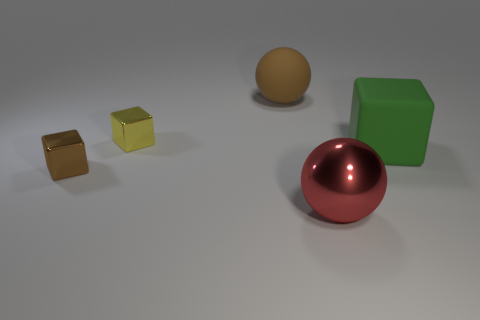There is a small thing that is in front of the big block; is its color the same as the big matte ball?
Provide a succinct answer. Yes. Is the number of blocks that are on the left side of the brown metal cube greater than the number of yellow shiny cubes?
Provide a succinct answer. No. What number of green objects are on the left side of the large rubber object that is to the right of the big red metallic ball?
Your answer should be compact. 0. Are the small block that is in front of the yellow cube and the ball that is in front of the large brown matte thing made of the same material?
Offer a terse response. Yes. There is a small cube that is the same color as the matte sphere; what is it made of?
Offer a very short reply. Metal. What number of green rubber objects are the same shape as the large red metallic object?
Ensure brevity in your answer.  0. Is the brown block made of the same material as the large thing in front of the green matte object?
Offer a terse response. Yes. There is a green block that is the same size as the metal sphere; what is it made of?
Keep it short and to the point. Rubber. Are there any brown matte objects that have the same size as the green matte object?
Your answer should be compact. Yes. There is another object that is the same size as the brown metallic object; what shape is it?
Provide a succinct answer. Cube. 